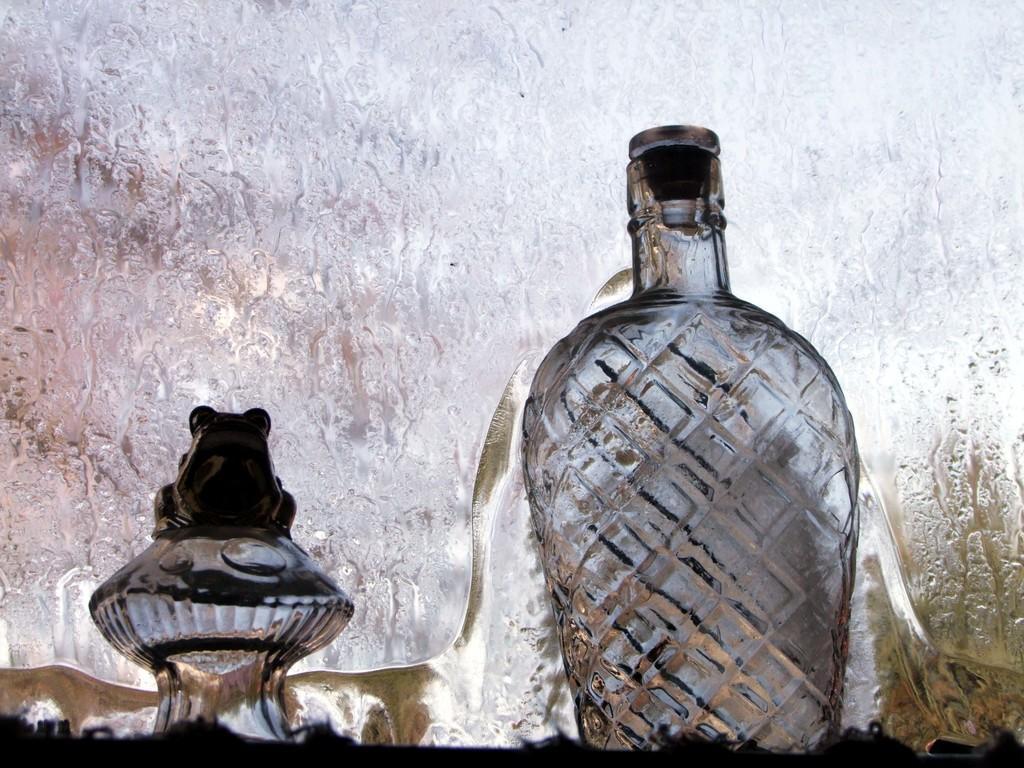Please provide a concise description of this image. In this image i can see a glass bottle and a object made of glass. 